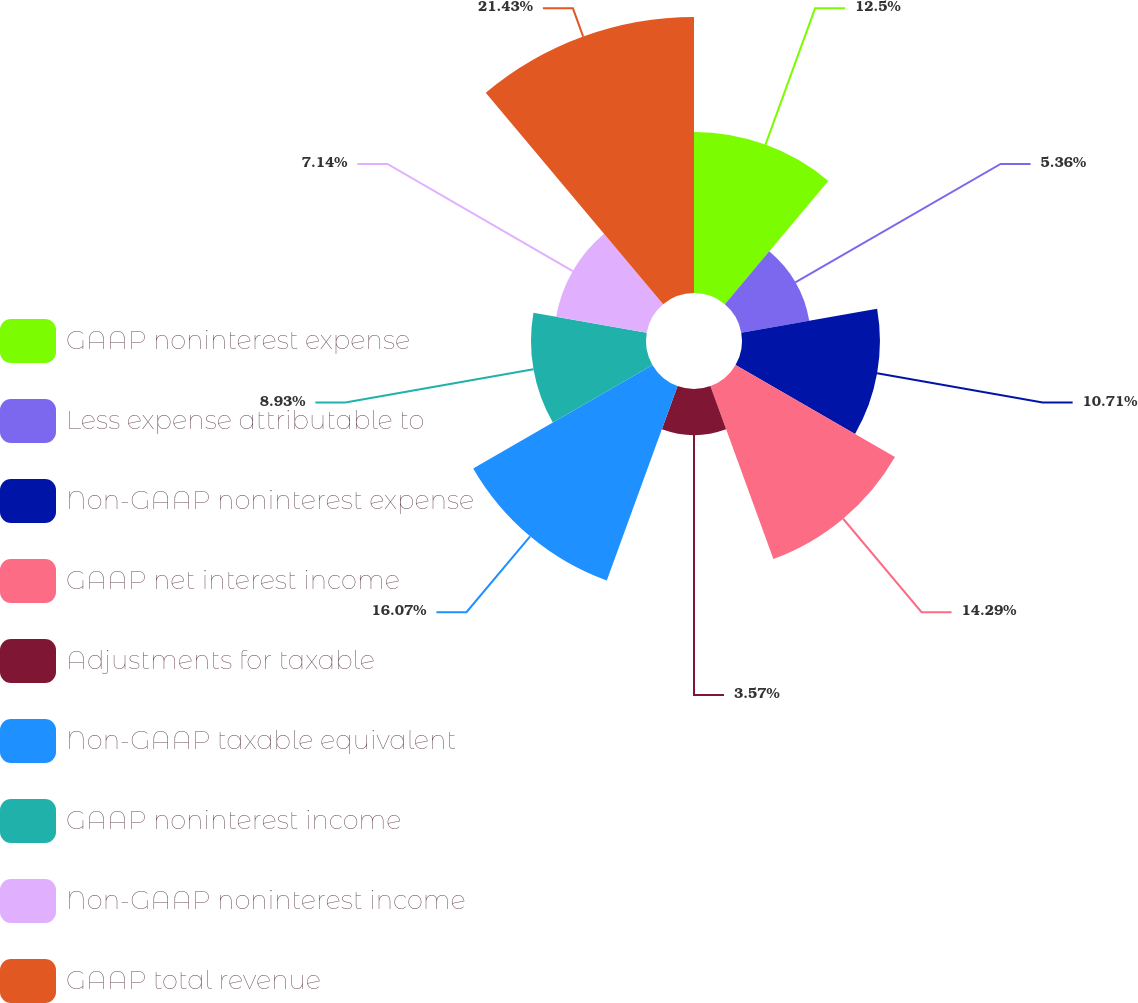Convert chart to OTSL. <chart><loc_0><loc_0><loc_500><loc_500><pie_chart><fcel>GAAP noninterest expense<fcel>Less expense attributable to<fcel>Non-GAAP noninterest expense<fcel>GAAP net interest income<fcel>Adjustments for taxable<fcel>Non-GAAP taxable equivalent<fcel>GAAP noninterest income<fcel>Non-GAAP noninterest income<fcel>GAAP total revenue<nl><fcel>12.5%<fcel>5.36%<fcel>10.71%<fcel>14.29%<fcel>3.57%<fcel>16.07%<fcel>8.93%<fcel>7.14%<fcel>21.43%<nl></chart> 